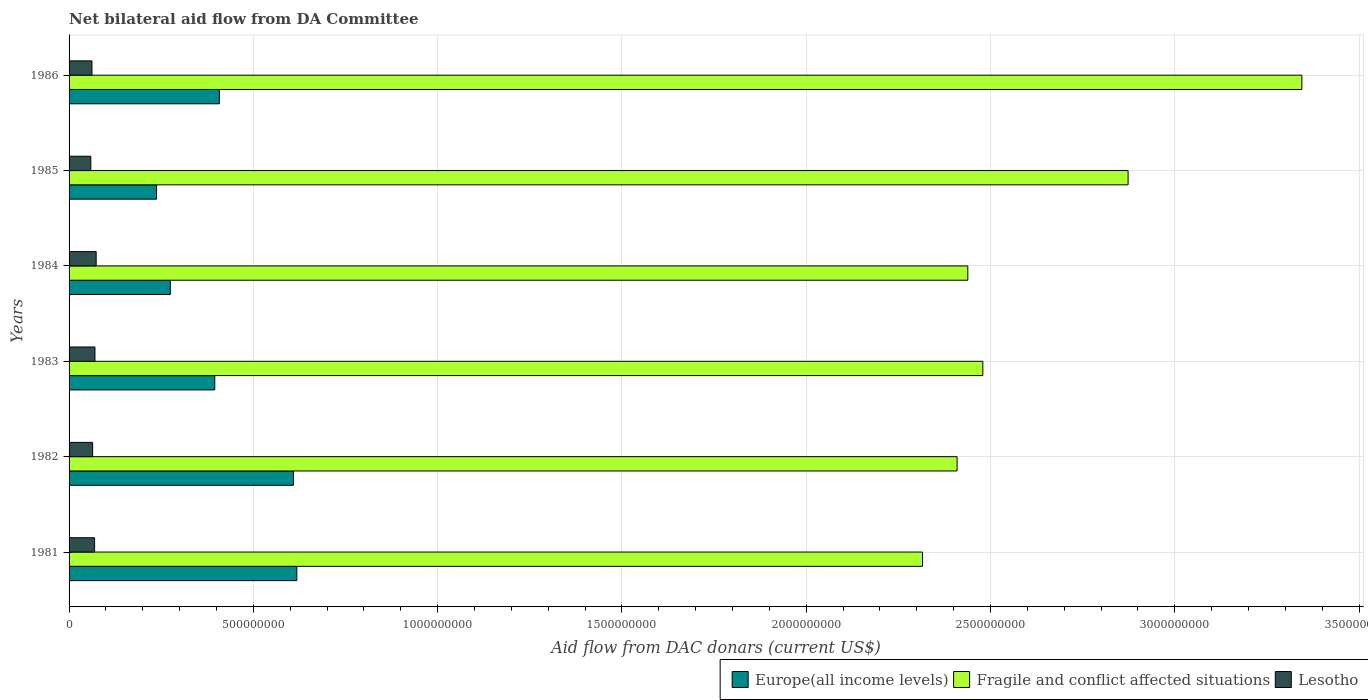How many different coloured bars are there?
Your answer should be very brief. 3. How many groups of bars are there?
Provide a succinct answer. 6. Are the number of bars on each tick of the Y-axis equal?
Keep it short and to the point. Yes. What is the aid flow in in Europe(all income levels) in 1985?
Offer a terse response. 2.37e+08. Across all years, what is the maximum aid flow in in Lesotho?
Make the answer very short. 7.35e+07. Across all years, what is the minimum aid flow in in Lesotho?
Offer a terse response. 5.90e+07. In which year was the aid flow in in Lesotho minimum?
Offer a very short reply. 1985. What is the total aid flow in in Lesotho in the graph?
Provide a succinct answer. 3.98e+08. What is the difference between the aid flow in in Europe(all income levels) in 1985 and that in 1986?
Your answer should be very brief. -1.71e+08. What is the difference between the aid flow in in Lesotho in 1985 and the aid flow in in Europe(all income levels) in 1984?
Keep it short and to the point. -2.16e+08. What is the average aid flow in in Fragile and conflict affected situations per year?
Give a very brief answer. 2.64e+09. In the year 1982, what is the difference between the aid flow in in Fragile and conflict affected situations and aid flow in in Lesotho?
Provide a short and direct response. 2.35e+09. In how many years, is the aid flow in in Europe(all income levels) greater than 500000000 US$?
Offer a terse response. 2. What is the ratio of the aid flow in in Fragile and conflict affected situations in 1983 to that in 1986?
Your answer should be very brief. 0.74. Is the aid flow in in Fragile and conflict affected situations in 1981 less than that in 1982?
Give a very brief answer. Yes. Is the difference between the aid flow in in Fragile and conflict affected situations in 1981 and 1985 greater than the difference between the aid flow in in Lesotho in 1981 and 1985?
Provide a succinct answer. No. What is the difference between the highest and the second highest aid flow in in Europe(all income levels)?
Ensure brevity in your answer.  9.05e+06. What is the difference between the highest and the lowest aid flow in in Fragile and conflict affected situations?
Provide a short and direct response. 1.03e+09. In how many years, is the aid flow in in Europe(all income levels) greater than the average aid flow in in Europe(all income levels) taken over all years?
Offer a terse response. 2. What does the 3rd bar from the top in 1982 represents?
Offer a very short reply. Europe(all income levels). What does the 3rd bar from the bottom in 1984 represents?
Offer a very short reply. Lesotho. Are all the bars in the graph horizontal?
Provide a short and direct response. Yes. What is the difference between two consecutive major ticks on the X-axis?
Provide a short and direct response. 5.00e+08. Where does the legend appear in the graph?
Provide a short and direct response. Bottom right. How many legend labels are there?
Ensure brevity in your answer.  3. How are the legend labels stacked?
Provide a succinct answer. Horizontal. What is the title of the graph?
Your response must be concise. Net bilateral aid flow from DA Committee. Does "Monaco" appear as one of the legend labels in the graph?
Offer a very short reply. No. What is the label or title of the X-axis?
Ensure brevity in your answer.  Aid flow from DAC donars (current US$). What is the Aid flow from DAC donars (current US$) of Europe(all income levels) in 1981?
Your response must be concise. 6.18e+08. What is the Aid flow from DAC donars (current US$) of Fragile and conflict affected situations in 1981?
Your answer should be very brief. 2.32e+09. What is the Aid flow from DAC donars (current US$) of Lesotho in 1981?
Ensure brevity in your answer.  6.92e+07. What is the Aid flow from DAC donars (current US$) of Europe(all income levels) in 1982?
Offer a terse response. 6.09e+08. What is the Aid flow from DAC donars (current US$) of Fragile and conflict affected situations in 1982?
Your answer should be very brief. 2.41e+09. What is the Aid flow from DAC donars (current US$) in Lesotho in 1982?
Offer a terse response. 6.39e+07. What is the Aid flow from DAC donars (current US$) in Europe(all income levels) in 1983?
Offer a terse response. 3.95e+08. What is the Aid flow from DAC donars (current US$) of Fragile and conflict affected situations in 1983?
Offer a very short reply. 2.48e+09. What is the Aid flow from DAC donars (current US$) of Lesotho in 1983?
Your answer should be compact. 7.02e+07. What is the Aid flow from DAC donars (current US$) of Europe(all income levels) in 1984?
Give a very brief answer. 2.75e+08. What is the Aid flow from DAC donars (current US$) in Fragile and conflict affected situations in 1984?
Keep it short and to the point. 2.44e+09. What is the Aid flow from DAC donars (current US$) in Lesotho in 1984?
Offer a very short reply. 7.35e+07. What is the Aid flow from DAC donars (current US$) in Europe(all income levels) in 1985?
Offer a very short reply. 2.37e+08. What is the Aid flow from DAC donars (current US$) in Fragile and conflict affected situations in 1985?
Offer a very short reply. 2.87e+09. What is the Aid flow from DAC donars (current US$) of Lesotho in 1985?
Give a very brief answer. 5.90e+07. What is the Aid flow from DAC donars (current US$) in Europe(all income levels) in 1986?
Offer a terse response. 4.08e+08. What is the Aid flow from DAC donars (current US$) in Fragile and conflict affected situations in 1986?
Ensure brevity in your answer.  3.34e+09. What is the Aid flow from DAC donars (current US$) of Lesotho in 1986?
Offer a terse response. 6.21e+07. Across all years, what is the maximum Aid flow from DAC donars (current US$) in Europe(all income levels)?
Offer a terse response. 6.18e+08. Across all years, what is the maximum Aid flow from DAC donars (current US$) in Fragile and conflict affected situations?
Give a very brief answer. 3.34e+09. Across all years, what is the maximum Aid flow from DAC donars (current US$) in Lesotho?
Offer a terse response. 7.35e+07. Across all years, what is the minimum Aid flow from DAC donars (current US$) of Europe(all income levels)?
Provide a short and direct response. 2.37e+08. Across all years, what is the minimum Aid flow from DAC donars (current US$) of Fragile and conflict affected situations?
Make the answer very short. 2.32e+09. Across all years, what is the minimum Aid flow from DAC donars (current US$) in Lesotho?
Ensure brevity in your answer.  5.90e+07. What is the total Aid flow from DAC donars (current US$) in Europe(all income levels) in the graph?
Ensure brevity in your answer.  2.54e+09. What is the total Aid flow from DAC donars (current US$) in Fragile and conflict affected situations in the graph?
Your response must be concise. 1.59e+1. What is the total Aid flow from DAC donars (current US$) of Lesotho in the graph?
Provide a succinct answer. 3.98e+08. What is the difference between the Aid flow from DAC donars (current US$) in Europe(all income levels) in 1981 and that in 1982?
Keep it short and to the point. 9.05e+06. What is the difference between the Aid flow from DAC donars (current US$) in Fragile and conflict affected situations in 1981 and that in 1982?
Your answer should be compact. -9.38e+07. What is the difference between the Aid flow from DAC donars (current US$) of Lesotho in 1981 and that in 1982?
Offer a very short reply. 5.31e+06. What is the difference between the Aid flow from DAC donars (current US$) in Europe(all income levels) in 1981 and that in 1983?
Your response must be concise. 2.23e+08. What is the difference between the Aid flow from DAC donars (current US$) in Fragile and conflict affected situations in 1981 and that in 1983?
Provide a succinct answer. -1.64e+08. What is the difference between the Aid flow from DAC donars (current US$) of Lesotho in 1981 and that in 1983?
Ensure brevity in your answer.  -1.00e+06. What is the difference between the Aid flow from DAC donars (current US$) in Europe(all income levels) in 1981 and that in 1984?
Your response must be concise. 3.43e+08. What is the difference between the Aid flow from DAC donars (current US$) of Fragile and conflict affected situations in 1981 and that in 1984?
Make the answer very short. -1.23e+08. What is the difference between the Aid flow from DAC donars (current US$) in Lesotho in 1981 and that in 1984?
Provide a succinct answer. -4.29e+06. What is the difference between the Aid flow from DAC donars (current US$) in Europe(all income levels) in 1981 and that in 1985?
Offer a terse response. 3.81e+08. What is the difference between the Aid flow from DAC donars (current US$) in Fragile and conflict affected situations in 1981 and that in 1985?
Your answer should be very brief. -5.58e+08. What is the difference between the Aid flow from DAC donars (current US$) in Lesotho in 1981 and that in 1985?
Make the answer very short. 1.02e+07. What is the difference between the Aid flow from DAC donars (current US$) in Europe(all income levels) in 1981 and that in 1986?
Provide a succinct answer. 2.10e+08. What is the difference between the Aid flow from DAC donars (current US$) in Fragile and conflict affected situations in 1981 and that in 1986?
Provide a short and direct response. -1.03e+09. What is the difference between the Aid flow from DAC donars (current US$) of Lesotho in 1981 and that in 1986?
Offer a very short reply. 7.12e+06. What is the difference between the Aid flow from DAC donars (current US$) of Europe(all income levels) in 1982 and that in 1983?
Make the answer very short. 2.14e+08. What is the difference between the Aid flow from DAC donars (current US$) in Fragile and conflict affected situations in 1982 and that in 1983?
Keep it short and to the point. -6.98e+07. What is the difference between the Aid flow from DAC donars (current US$) in Lesotho in 1982 and that in 1983?
Your answer should be very brief. -6.31e+06. What is the difference between the Aid flow from DAC donars (current US$) of Europe(all income levels) in 1982 and that in 1984?
Your response must be concise. 3.34e+08. What is the difference between the Aid flow from DAC donars (current US$) in Fragile and conflict affected situations in 1982 and that in 1984?
Make the answer very short. -2.90e+07. What is the difference between the Aid flow from DAC donars (current US$) of Lesotho in 1982 and that in 1984?
Keep it short and to the point. -9.60e+06. What is the difference between the Aid flow from DAC donars (current US$) of Europe(all income levels) in 1982 and that in 1985?
Provide a short and direct response. 3.72e+08. What is the difference between the Aid flow from DAC donars (current US$) of Fragile and conflict affected situations in 1982 and that in 1985?
Offer a terse response. -4.64e+08. What is the difference between the Aid flow from DAC donars (current US$) in Lesotho in 1982 and that in 1985?
Provide a short and direct response. 4.93e+06. What is the difference between the Aid flow from DAC donars (current US$) in Europe(all income levels) in 1982 and that in 1986?
Offer a very short reply. 2.01e+08. What is the difference between the Aid flow from DAC donars (current US$) in Fragile and conflict affected situations in 1982 and that in 1986?
Your answer should be compact. -9.35e+08. What is the difference between the Aid flow from DAC donars (current US$) of Lesotho in 1982 and that in 1986?
Offer a terse response. 1.81e+06. What is the difference between the Aid flow from DAC donars (current US$) of Europe(all income levels) in 1983 and that in 1984?
Provide a short and direct response. 1.21e+08. What is the difference between the Aid flow from DAC donars (current US$) of Fragile and conflict affected situations in 1983 and that in 1984?
Your answer should be compact. 4.08e+07. What is the difference between the Aid flow from DAC donars (current US$) in Lesotho in 1983 and that in 1984?
Your answer should be compact. -3.29e+06. What is the difference between the Aid flow from DAC donars (current US$) of Europe(all income levels) in 1983 and that in 1985?
Keep it short and to the point. 1.58e+08. What is the difference between the Aid flow from DAC donars (current US$) in Fragile and conflict affected situations in 1983 and that in 1985?
Your answer should be compact. -3.94e+08. What is the difference between the Aid flow from DAC donars (current US$) in Lesotho in 1983 and that in 1985?
Offer a very short reply. 1.12e+07. What is the difference between the Aid flow from DAC donars (current US$) of Europe(all income levels) in 1983 and that in 1986?
Keep it short and to the point. -1.25e+07. What is the difference between the Aid flow from DAC donars (current US$) in Fragile and conflict affected situations in 1983 and that in 1986?
Your response must be concise. -8.66e+08. What is the difference between the Aid flow from DAC donars (current US$) in Lesotho in 1983 and that in 1986?
Your answer should be very brief. 8.12e+06. What is the difference between the Aid flow from DAC donars (current US$) of Europe(all income levels) in 1984 and that in 1985?
Your answer should be very brief. 3.75e+07. What is the difference between the Aid flow from DAC donars (current US$) of Fragile and conflict affected situations in 1984 and that in 1985?
Provide a short and direct response. -4.35e+08. What is the difference between the Aid flow from DAC donars (current US$) in Lesotho in 1984 and that in 1985?
Provide a succinct answer. 1.45e+07. What is the difference between the Aid flow from DAC donars (current US$) of Europe(all income levels) in 1984 and that in 1986?
Provide a short and direct response. -1.33e+08. What is the difference between the Aid flow from DAC donars (current US$) in Fragile and conflict affected situations in 1984 and that in 1986?
Provide a succinct answer. -9.06e+08. What is the difference between the Aid flow from DAC donars (current US$) of Lesotho in 1984 and that in 1986?
Offer a very short reply. 1.14e+07. What is the difference between the Aid flow from DAC donars (current US$) of Europe(all income levels) in 1985 and that in 1986?
Your answer should be very brief. -1.71e+08. What is the difference between the Aid flow from DAC donars (current US$) in Fragile and conflict affected situations in 1985 and that in 1986?
Provide a short and direct response. -4.71e+08. What is the difference between the Aid flow from DAC donars (current US$) of Lesotho in 1985 and that in 1986?
Your answer should be compact. -3.12e+06. What is the difference between the Aid flow from DAC donars (current US$) in Europe(all income levels) in 1981 and the Aid flow from DAC donars (current US$) in Fragile and conflict affected situations in 1982?
Offer a terse response. -1.79e+09. What is the difference between the Aid flow from DAC donars (current US$) in Europe(all income levels) in 1981 and the Aid flow from DAC donars (current US$) in Lesotho in 1982?
Your answer should be very brief. 5.54e+08. What is the difference between the Aid flow from DAC donars (current US$) in Fragile and conflict affected situations in 1981 and the Aid flow from DAC donars (current US$) in Lesotho in 1982?
Ensure brevity in your answer.  2.25e+09. What is the difference between the Aid flow from DAC donars (current US$) of Europe(all income levels) in 1981 and the Aid flow from DAC donars (current US$) of Fragile and conflict affected situations in 1983?
Make the answer very short. -1.86e+09. What is the difference between the Aid flow from DAC donars (current US$) in Europe(all income levels) in 1981 and the Aid flow from DAC donars (current US$) in Lesotho in 1983?
Ensure brevity in your answer.  5.48e+08. What is the difference between the Aid flow from DAC donars (current US$) of Fragile and conflict affected situations in 1981 and the Aid flow from DAC donars (current US$) of Lesotho in 1983?
Your answer should be very brief. 2.25e+09. What is the difference between the Aid flow from DAC donars (current US$) in Europe(all income levels) in 1981 and the Aid flow from DAC donars (current US$) in Fragile and conflict affected situations in 1984?
Offer a terse response. -1.82e+09. What is the difference between the Aid flow from DAC donars (current US$) of Europe(all income levels) in 1981 and the Aid flow from DAC donars (current US$) of Lesotho in 1984?
Your answer should be compact. 5.44e+08. What is the difference between the Aid flow from DAC donars (current US$) of Fragile and conflict affected situations in 1981 and the Aid flow from DAC donars (current US$) of Lesotho in 1984?
Provide a short and direct response. 2.24e+09. What is the difference between the Aid flow from DAC donars (current US$) in Europe(all income levels) in 1981 and the Aid flow from DAC donars (current US$) in Fragile and conflict affected situations in 1985?
Your answer should be very brief. -2.26e+09. What is the difference between the Aid flow from DAC donars (current US$) of Europe(all income levels) in 1981 and the Aid flow from DAC donars (current US$) of Lesotho in 1985?
Offer a very short reply. 5.59e+08. What is the difference between the Aid flow from DAC donars (current US$) of Fragile and conflict affected situations in 1981 and the Aid flow from DAC donars (current US$) of Lesotho in 1985?
Your answer should be compact. 2.26e+09. What is the difference between the Aid flow from DAC donars (current US$) of Europe(all income levels) in 1981 and the Aid flow from DAC donars (current US$) of Fragile and conflict affected situations in 1986?
Provide a short and direct response. -2.73e+09. What is the difference between the Aid flow from DAC donars (current US$) of Europe(all income levels) in 1981 and the Aid flow from DAC donars (current US$) of Lesotho in 1986?
Give a very brief answer. 5.56e+08. What is the difference between the Aid flow from DAC donars (current US$) in Fragile and conflict affected situations in 1981 and the Aid flow from DAC donars (current US$) in Lesotho in 1986?
Keep it short and to the point. 2.25e+09. What is the difference between the Aid flow from DAC donars (current US$) of Europe(all income levels) in 1982 and the Aid flow from DAC donars (current US$) of Fragile and conflict affected situations in 1983?
Your response must be concise. -1.87e+09. What is the difference between the Aid flow from DAC donars (current US$) in Europe(all income levels) in 1982 and the Aid flow from DAC donars (current US$) in Lesotho in 1983?
Ensure brevity in your answer.  5.39e+08. What is the difference between the Aid flow from DAC donars (current US$) of Fragile and conflict affected situations in 1982 and the Aid flow from DAC donars (current US$) of Lesotho in 1983?
Your answer should be compact. 2.34e+09. What is the difference between the Aid flow from DAC donars (current US$) in Europe(all income levels) in 1982 and the Aid flow from DAC donars (current US$) in Fragile and conflict affected situations in 1984?
Give a very brief answer. -1.83e+09. What is the difference between the Aid flow from DAC donars (current US$) in Europe(all income levels) in 1982 and the Aid flow from DAC donars (current US$) in Lesotho in 1984?
Offer a terse response. 5.35e+08. What is the difference between the Aid flow from DAC donars (current US$) of Fragile and conflict affected situations in 1982 and the Aid flow from DAC donars (current US$) of Lesotho in 1984?
Offer a very short reply. 2.34e+09. What is the difference between the Aid flow from DAC donars (current US$) in Europe(all income levels) in 1982 and the Aid flow from DAC donars (current US$) in Fragile and conflict affected situations in 1985?
Your answer should be very brief. -2.26e+09. What is the difference between the Aid flow from DAC donars (current US$) in Europe(all income levels) in 1982 and the Aid flow from DAC donars (current US$) in Lesotho in 1985?
Offer a terse response. 5.50e+08. What is the difference between the Aid flow from DAC donars (current US$) of Fragile and conflict affected situations in 1982 and the Aid flow from DAC donars (current US$) of Lesotho in 1985?
Offer a very short reply. 2.35e+09. What is the difference between the Aid flow from DAC donars (current US$) in Europe(all income levels) in 1982 and the Aid flow from DAC donars (current US$) in Fragile and conflict affected situations in 1986?
Your answer should be very brief. -2.74e+09. What is the difference between the Aid flow from DAC donars (current US$) of Europe(all income levels) in 1982 and the Aid flow from DAC donars (current US$) of Lesotho in 1986?
Provide a succinct answer. 5.47e+08. What is the difference between the Aid flow from DAC donars (current US$) in Fragile and conflict affected situations in 1982 and the Aid flow from DAC donars (current US$) in Lesotho in 1986?
Make the answer very short. 2.35e+09. What is the difference between the Aid flow from DAC donars (current US$) in Europe(all income levels) in 1983 and the Aid flow from DAC donars (current US$) in Fragile and conflict affected situations in 1984?
Offer a terse response. -2.04e+09. What is the difference between the Aid flow from DAC donars (current US$) in Europe(all income levels) in 1983 and the Aid flow from DAC donars (current US$) in Lesotho in 1984?
Keep it short and to the point. 3.22e+08. What is the difference between the Aid flow from DAC donars (current US$) in Fragile and conflict affected situations in 1983 and the Aid flow from DAC donars (current US$) in Lesotho in 1984?
Make the answer very short. 2.41e+09. What is the difference between the Aid flow from DAC donars (current US$) in Europe(all income levels) in 1983 and the Aid flow from DAC donars (current US$) in Fragile and conflict affected situations in 1985?
Offer a very short reply. -2.48e+09. What is the difference between the Aid flow from DAC donars (current US$) in Europe(all income levels) in 1983 and the Aid flow from DAC donars (current US$) in Lesotho in 1985?
Offer a very short reply. 3.36e+08. What is the difference between the Aid flow from DAC donars (current US$) in Fragile and conflict affected situations in 1983 and the Aid flow from DAC donars (current US$) in Lesotho in 1985?
Keep it short and to the point. 2.42e+09. What is the difference between the Aid flow from DAC donars (current US$) in Europe(all income levels) in 1983 and the Aid flow from DAC donars (current US$) in Fragile and conflict affected situations in 1986?
Provide a succinct answer. -2.95e+09. What is the difference between the Aid flow from DAC donars (current US$) in Europe(all income levels) in 1983 and the Aid flow from DAC donars (current US$) in Lesotho in 1986?
Offer a very short reply. 3.33e+08. What is the difference between the Aid flow from DAC donars (current US$) in Fragile and conflict affected situations in 1983 and the Aid flow from DAC donars (current US$) in Lesotho in 1986?
Your response must be concise. 2.42e+09. What is the difference between the Aid flow from DAC donars (current US$) of Europe(all income levels) in 1984 and the Aid flow from DAC donars (current US$) of Fragile and conflict affected situations in 1985?
Keep it short and to the point. -2.60e+09. What is the difference between the Aid flow from DAC donars (current US$) in Europe(all income levels) in 1984 and the Aid flow from DAC donars (current US$) in Lesotho in 1985?
Keep it short and to the point. 2.16e+08. What is the difference between the Aid flow from DAC donars (current US$) in Fragile and conflict affected situations in 1984 and the Aid flow from DAC donars (current US$) in Lesotho in 1985?
Give a very brief answer. 2.38e+09. What is the difference between the Aid flow from DAC donars (current US$) of Europe(all income levels) in 1984 and the Aid flow from DAC donars (current US$) of Fragile and conflict affected situations in 1986?
Your answer should be very brief. -3.07e+09. What is the difference between the Aid flow from DAC donars (current US$) of Europe(all income levels) in 1984 and the Aid flow from DAC donars (current US$) of Lesotho in 1986?
Your answer should be very brief. 2.13e+08. What is the difference between the Aid flow from DAC donars (current US$) in Fragile and conflict affected situations in 1984 and the Aid flow from DAC donars (current US$) in Lesotho in 1986?
Offer a very short reply. 2.38e+09. What is the difference between the Aid flow from DAC donars (current US$) in Europe(all income levels) in 1985 and the Aid flow from DAC donars (current US$) in Fragile and conflict affected situations in 1986?
Provide a short and direct response. -3.11e+09. What is the difference between the Aid flow from DAC donars (current US$) in Europe(all income levels) in 1985 and the Aid flow from DAC donars (current US$) in Lesotho in 1986?
Ensure brevity in your answer.  1.75e+08. What is the difference between the Aid flow from DAC donars (current US$) in Fragile and conflict affected situations in 1985 and the Aid flow from DAC donars (current US$) in Lesotho in 1986?
Offer a terse response. 2.81e+09. What is the average Aid flow from DAC donars (current US$) in Europe(all income levels) per year?
Make the answer very short. 4.24e+08. What is the average Aid flow from DAC donars (current US$) in Fragile and conflict affected situations per year?
Ensure brevity in your answer.  2.64e+09. What is the average Aid flow from DAC donars (current US$) in Lesotho per year?
Give a very brief answer. 6.63e+07. In the year 1981, what is the difference between the Aid flow from DAC donars (current US$) in Europe(all income levels) and Aid flow from DAC donars (current US$) in Fragile and conflict affected situations?
Ensure brevity in your answer.  -1.70e+09. In the year 1981, what is the difference between the Aid flow from DAC donars (current US$) in Europe(all income levels) and Aid flow from DAC donars (current US$) in Lesotho?
Your answer should be very brief. 5.49e+08. In the year 1981, what is the difference between the Aid flow from DAC donars (current US$) in Fragile and conflict affected situations and Aid flow from DAC donars (current US$) in Lesotho?
Offer a very short reply. 2.25e+09. In the year 1982, what is the difference between the Aid flow from DAC donars (current US$) in Europe(all income levels) and Aid flow from DAC donars (current US$) in Fragile and conflict affected situations?
Offer a very short reply. -1.80e+09. In the year 1982, what is the difference between the Aid flow from DAC donars (current US$) in Europe(all income levels) and Aid flow from DAC donars (current US$) in Lesotho?
Provide a short and direct response. 5.45e+08. In the year 1982, what is the difference between the Aid flow from DAC donars (current US$) of Fragile and conflict affected situations and Aid flow from DAC donars (current US$) of Lesotho?
Provide a short and direct response. 2.35e+09. In the year 1983, what is the difference between the Aid flow from DAC donars (current US$) in Europe(all income levels) and Aid flow from DAC donars (current US$) in Fragile and conflict affected situations?
Make the answer very short. -2.08e+09. In the year 1983, what is the difference between the Aid flow from DAC donars (current US$) of Europe(all income levels) and Aid flow from DAC donars (current US$) of Lesotho?
Your response must be concise. 3.25e+08. In the year 1983, what is the difference between the Aid flow from DAC donars (current US$) in Fragile and conflict affected situations and Aid flow from DAC donars (current US$) in Lesotho?
Offer a terse response. 2.41e+09. In the year 1984, what is the difference between the Aid flow from DAC donars (current US$) of Europe(all income levels) and Aid flow from DAC donars (current US$) of Fragile and conflict affected situations?
Your response must be concise. -2.16e+09. In the year 1984, what is the difference between the Aid flow from DAC donars (current US$) in Europe(all income levels) and Aid flow from DAC donars (current US$) in Lesotho?
Offer a terse response. 2.01e+08. In the year 1984, what is the difference between the Aid flow from DAC donars (current US$) in Fragile and conflict affected situations and Aid flow from DAC donars (current US$) in Lesotho?
Provide a short and direct response. 2.36e+09. In the year 1985, what is the difference between the Aid flow from DAC donars (current US$) in Europe(all income levels) and Aid flow from DAC donars (current US$) in Fragile and conflict affected situations?
Ensure brevity in your answer.  -2.64e+09. In the year 1985, what is the difference between the Aid flow from DAC donars (current US$) of Europe(all income levels) and Aid flow from DAC donars (current US$) of Lesotho?
Offer a very short reply. 1.78e+08. In the year 1985, what is the difference between the Aid flow from DAC donars (current US$) in Fragile and conflict affected situations and Aid flow from DAC donars (current US$) in Lesotho?
Make the answer very short. 2.81e+09. In the year 1986, what is the difference between the Aid flow from DAC donars (current US$) of Europe(all income levels) and Aid flow from DAC donars (current US$) of Fragile and conflict affected situations?
Offer a very short reply. -2.94e+09. In the year 1986, what is the difference between the Aid flow from DAC donars (current US$) in Europe(all income levels) and Aid flow from DAC donars (current US$) in Lesotho?
Your answer should be very brief. 3.46e+08. In the year 1986, what is the difference between the Aid flow from DAC donars (current US$) in Fragile and conflict affected situations and Aid flow from DAC donars (current US$) in Lesotho?
Offer a terse response. 3.28e+09. What is the ratio of the Aid flow from DAC donars (current US$) of Europe(all income levels) in 1981 to that in 1982?
Ensure brevity in your answer.  1.01. What is the ratio of the Aid flow from DAC donars (current US$) of Fragile and conflict affected situations in 1981 to that in 1982?
Ensure brevity in your answer.  0.96. What is the ratio of the Aid flow from DAC donars (current US$) of Lesotho in 1981 to that in 1982?
Provide a succinct answer. 1.08. What is the ratio of the Aid flow from DAC donars (current US$) of Europe(all income levels) in 1981 to that in 1983?
Provide a short and direct response. 1.56. What is the ratio of the Aid flow from DAC donars (current US$) in Fragile and conflict affected situations in 1981 to that in 1983?
Your answer should be compact. 0.93. What is the ratio of the Aid flow from DAC donars (current US$) in Lesotho in 1981 to that in 1983?
Keep it short and to the point. 0.99. What is the ratio of the Aid flow from DAC donars (current US$) of Europe(all income levels) in 1981 to that in 1984?
Make the answer very short. 2.25. What is the ratio of the Aid flow from DAC donars (current US$) in Fragile and conflict affected situations in 1981 to that in 1984?
Provide a succinct answer. 0.95. What is the ratio of the Aid flow from DAC donars (current US$) of Lesotho in 1981 to that in 1984?
Your answer should be very brief. 0.94. What is the ratio of the Aid flow from DAC donars (current US$) of Europe(all income levels) in 1981 to that in 1985?
Provide a short and direct response. 2.6. What is the ratio of the Aid flow from DAC donars (current US$) of Fragile and conflict affected situations in 1981 to that in 1985?
Provide a succinct answer. 0.81. What is the ratio of the Aid flow from DAC donars (current US$) of Lesotho in 1981 to that in 1985?
Your answer should be compact. 1.17. What is the ratio of the Aid flow from DAC donars (current US$) of Europe(all income levels) in 1981 to that in 1986?
Offer a terse response. 1.52. What is the ratio of the Aid flow from DAC donars (current US$) in Fragile and conflict affected situations in 1981 to that in 1986?
Ensure brevity in your answer.  0.69. What is the ratio of the Aid flow from DAC donars (current US$) of Lesotho in 1981 to that in 1986?
Keep it short and to the point. 1.11. What is the ratio of the Aid flow from DAC donars (current US$) of Europe(all income levels) in 1982 to that in 1983?
Offer a terse response. 1.54. What is the ratio of the Aid flow from DAC donars (current US$) of Fragile and conflict affected situations in 1982 to that in 1983?
Ensure brevity in your answer.  0.97. What is the ratio of the Aid flow from DAC donars (current US$) of Lesotho in 1982 to that in 1983?
Provide a short and direct response. 0.91. What is the ratio of the Aid flow from DAC donars (current US$) of Europe(all income levels) in 1982 to that in 1984?
Keep it short and to the point. 2.22. What is the ratio of the Aid flow from DAC donars (current US$) in Lesotho in 1982 to that in 1984?
Make the answer very short. 0.87. What is the ratio of the Aid flow from DAC donars (current US$) of Europe(all income levels) in 1982 to that in 1985?
Your answer should be compact. 2.57. What is the ratio of the Aid flow from DAC donars (current US$) of Fragile and conflict affected situations in 1982 to that in 1985?
Provide a short and direct response. 0.84. What is the ratio of the Aid flow from DAC donars (current US$) of Lesotho in 1982 to that in 1985?
Ensure brevity in your answer.  1.08. What is the ratio of the Aid flow from DAC donars (current US$) of Europe(all income levels) in 1982 to that in 1986?
Offer a very short reply. 1.49. What is the ratio of the Aid flow from DAC donars (current US$) of Fragile and conflict affected situations in 1982 to that in 1986?
Provide a short and direct response. 0.72. What is the ratio of the Aid flow from DAC donars (current US$) in Lesotho in 1982 to that in 1986?
Ensure brevity in your answer.  1.03. What is the ratio of the Aid flow from DAC donars (current US$) of Europe(all income levels) in 1983 to that in 1984?
Keep it short and to the point. 1.44. What is the ratio of the Aid flow from DAC donars (current US$) of Fragile and conflict affected situations in 1983 to that in 1984?
Ensure brevity in your answer.  1.02. What is the ratio of the Aid flow from DAC donars (current US$) of Lesotho in 1983 to that in 1984?
Give a very brief answer. 0.96. What is the ratio of the Aid flow from DAC donars (current US$) in Europe(all income levels) in 1983 to that in 1985?
Your answer should be very brief. 1.67. What is the ratio of the Aid flow from DAC donars (current US$) in Fragile and conflict affected situations in 1983 to that in 1985?
Offer a very short reply. 0.86. What is the ratio of the Aid flow from DAC donars (current US$) of Lesotho in 1983 to that in 1985?
Offer a terse response. 1.19. What is the ratio of the Aid flow from DAC donars (current US$) of Europe(all income levels) in 1983 to that in 1986?
Your response must be concise. 0.97. What is the ratio of the Aid flow from DAC donars (current US$) in Fragile and conflict affected situations in 1983 to that in 1986?
Make the answer very short. 0.74. What is the ratio of the Aid flow from DAC donars (current US$) of Lesotho in 1983 to that in 1986?
Your answer should be compact. 1.13. What is the ratio of the Aid flow from DAC donars (current US$) of Europe(all income levels) in 1984 to that in 1985?
Keep it short and to the point. 1.16. What is the ratio of the Aid flow from DAC donars (current US$) of Fragile and conflict affected situations in 1984 to that in 1985?
Give a very brief answer. 0.85. What is the ratio of the Aid flow from DAC donars (current US$) in Lesotho in 1984 to that in 1985?
Provide a succinct answer. 1.25. What is the ratio of the Aid flow from DAC donars (current US$) in Europe(all income levels) in 1984 to that in 1986?
Make the answer very short. 0.67. What is the ratio of the Aid flow from DAC donars (current US$) in Fragile and conflict affected situations in 1984 to that in 1986?
Keep it short and to the point. 0.73. What is the ratio of the Aid flow from DAC donars (current US$) of Lesotho in 1984 to that in 1986?
Your response must be concise. 1.18. What is the ratio of the Aid flow from DAC donars (current US$) in Europe(all income levels) in 1985 to that in 1986?
Ensure brevity in your answer.  0.58. What is the ratio of the Aid flow from DAC donars (current US$) of Fragile and conflict affected situations in 1985 to that in 1986?
Make the answer very short. 0.86. What is the ratio of the Aid flow from DAC donars (current US$) of Lesotho in 1985 to that in 1986?
Your response must be concise. 0.95. What is the difference between the highest and the second highest Aid flow from DAC donars (current US$) in Europe(all income levels)?
Provide a short and direct response. 9.05e+06. What is the difference between the highest and the second highest Aid flow from DAC donars (current US$) in Fragile and conflict affected situations?
Your answer should be very brief. 4.71e+08. What is the difference between the highest and the second highest Aid flow from DAC donars (current US$) in Lesotho?
Ensure brevity in your answer.  3.29e+06. What is the difference between the highest and the lowest Aid flow from DAC donars (current US$) of Europe(all income levels)?
Provide a short and direct response. 3.81e+08. What is the difference between the highest and the lowest Aid flow from DAC donars (current US$) of Fragile and conflict affected situations?
Offer a terse response. 1.03e+09. What is the difference between the highest and the lowest Aid flow from DAC donars (current US$) in Lesotho?
Offer a very short reply. 1.45e+07. 